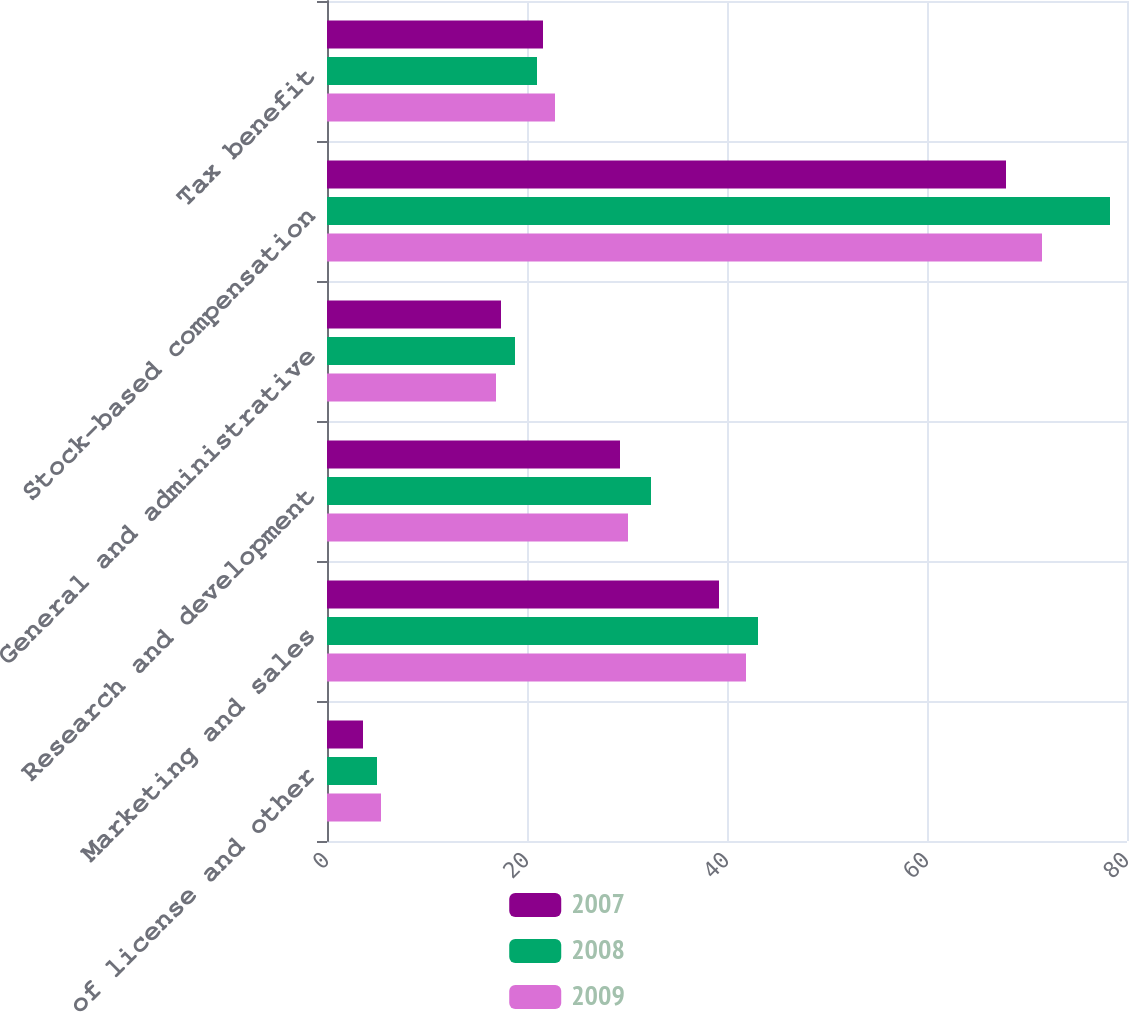<chart> <loc_0><loc_0><loc_500><loc_500><stacked_bar_chart><ecel><fcel>Cost of license and other<fcel>Marketing and sales<fcel>Research and development<fcel>General and administrative<fcel>Stock-based compensation<fcel>Tax benefit<nl><fcel>2007<fcel>3.6<fcel>39.2<fcel>29.3<fcel>17.4<fcel>67.9<fcel>21.6<nl><fcel>2008<fcel>5<fcel>43.1<fcel>32.4<fcel>18.8<fcel>78.3<fcel>21<nl><fcel>2009<fcel>5.4<fcel>41.9<fcel>30.1<fcel>16.9<fcel>71.5<fcel>22.8<nl></chart> 